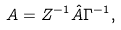<formula> <loc_0><loc_0><loc_500><loc_500>A = Z ^ { - 1 } \hat { A } \Gamma ^ { - 1 } ,</formula> 